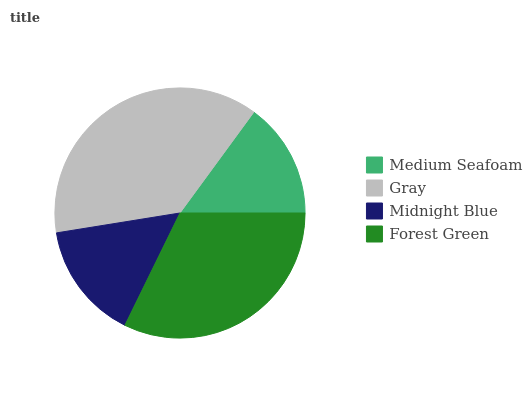Is Medium Seafoam the minimum?
Answer yes or no. Yes. Is Gray the maximum?
Answer yes or no. Yes. Is Midnight Blue the minimum?
Answer yes or no. No. Is Midnight Blue the maximum?
Answer yes or no. No. Is Gray greater than Midnight Blue?
Answer yes or no. Yes. Is Midnight Blue less than Gray?
Answer yes or no. Yes. Is Midnight Blue greater than Gray?
Answer yes or no. No. Is Gray less than Midnight Blue?
Answer yes or no. No. Is Forest Green the high median?
Answer yes or no. Yes. Is Midnight Blue the low median?
Answer yes or no. Yes. Is Midnight Blue the high median?
Answer yes or no. No. Is Gray the low median?
Answer yes or no. No. 